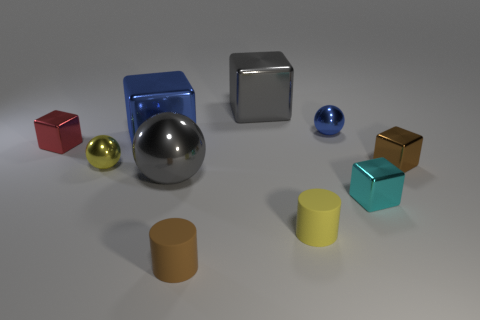There is a rubber thing that is in front of the tiny yellow matte cylinder to the left of the brown block; what size is it?
Your answer should be compact. Small. Is the brown thing left of the large gray block made of the same material as the small brown object that is right of the small brown matte thing?
Your answer should be compact. No. There is a tiny ball that is right of the blue metallic block; is its color the same as the large sphere?
Make the answer very short. No. There is a tiny yellow rubber thing; how many small brown cylinders are behind it?
Ensure brevity in your answer.  0. Is the material of the small red thing the same as the brown thing that is behind the small brown matte cylinder?
Give a very brief answer. Yes. What size is the blue cube that is the same material as the large gray cube?
Make the answer very short. Large. Is the number of yellow metallic objects on the right side of the yellow shiny object greater than the number of gray spheres behind the gray cube?
Your answer should be very brief. No. Is there a cyan object that has the same shape as the small yellow rubber thing?
Keep it short and to the point. No. There is a metal ball that is in front of the yellow sphere; is it the same size as the tiny yellow cylinder?
Provide a succinct answer. No. Are there any small gray things?
Offer a very short reply. No. 